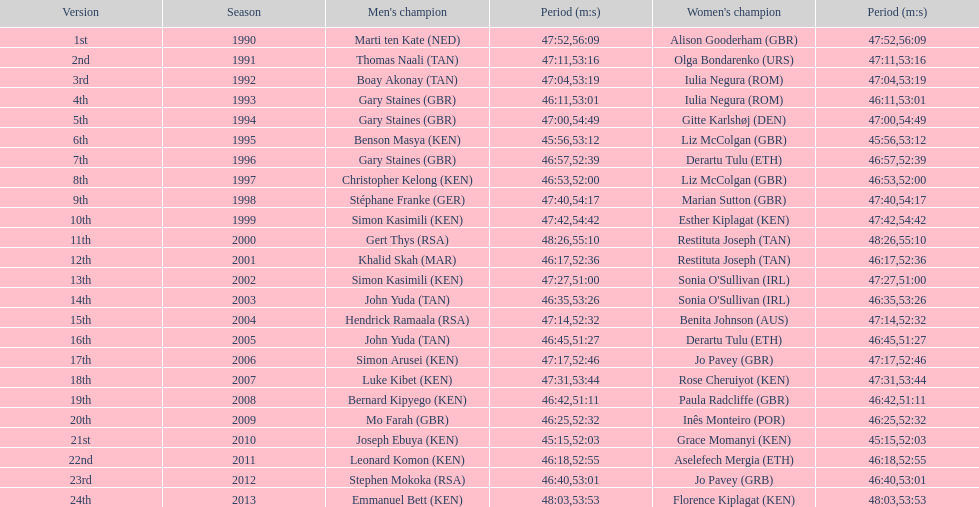How many men winners had times at least 46 minutes or under? 2. 